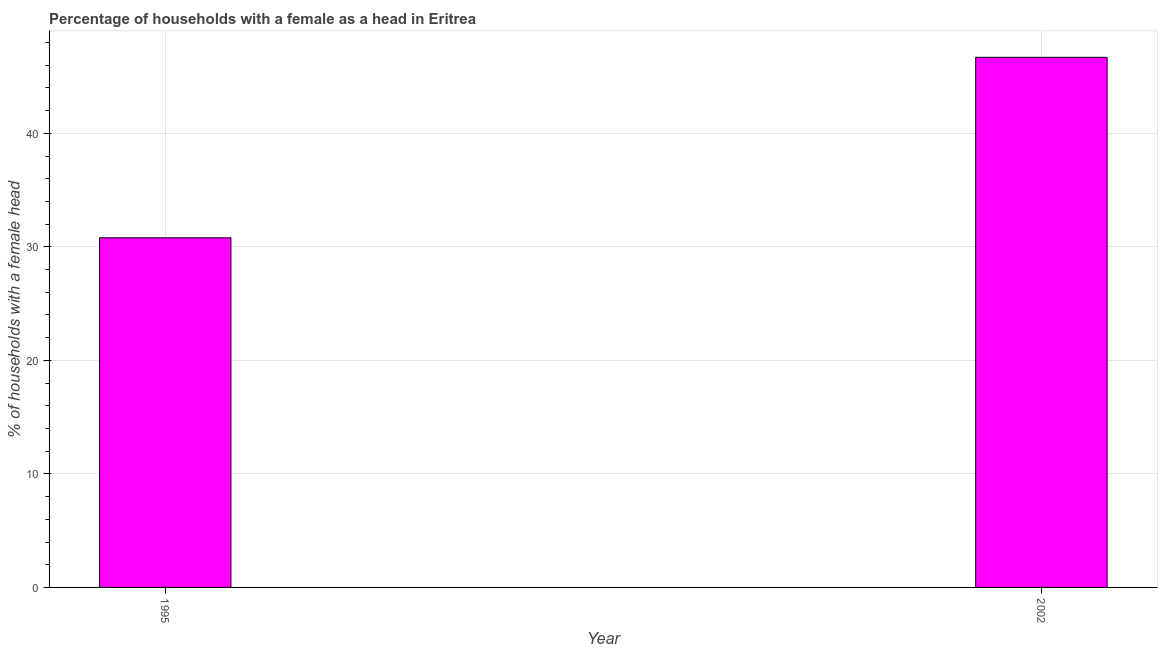What is the title of the graph?
Your answer should be compact. Percentage of households with a female as a head in Eritrea. What is the label or title of the Y-axis?
Your answer should be very brief. % of households with a female head. What is the number of female supervised households in 1995?
Ensure brevity in your answer.  30.8. Across all years, what is the maximum number of female supervised households?
Give a very brief answer. 46.7. Across all years, what is the minimum number of female supervised households?
Offer a very short reply. 30.8. In which year was the number of female supervised households maximum?
Ensure brevity in your answer.  2002. In which year was the number of female supervised households minimum?
Provide a succinct answer. 1995. What is the sum of the number of female supervised households?
Your response must be concise. 77.5. What is the difference between the number of female supervised households in 1995 and 2002?
Provide a succinct answer. -15.9. What is the average number of female supervised households per year?
Your answer should be compact. 38.75. What is the median number of female supervised households?
Your response must be concise. 38.75. Do a majority of the years between 2002 and 1995 (inclusive) have number of female supervised households greater than 28 %?
Offer a terse response. No. What is the ratio of the number of female supervised households in 1995 to that in 2002?
Provide a succinct answer. 0.66. Is the number of female supervised households in 1995 less than that in 2002?
Offer a terse response. Yes. Are all the bars in the graph horizontal?
Give a very brief answer. No. How many years are there in the graph?
Your answer should be very brief. 2. What is the difference between two consecutive major ticks on the Y-axis?
Provide a succinct answer. 10. What is the % of households with a female head of 1995?
Offer a very short reply. 30.8. What is the % of households with a female head in 2002?
Provide a succinct answer. 46.7. What is the difference between the % of households with a female head in 1995 and 2002?
Offer a terse response. -15.9. What is the ratio of the % of households with a female head in 1995 to that in 2002?
Ensure brevity in your answer.  0.66. 